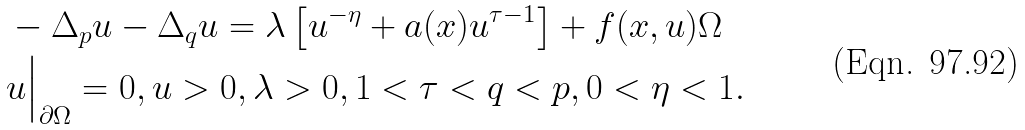<formula> <loc_0><loc_0><loc_500><loc_500>& - \Delta _ { p } u - \Delta _ { q } u = \lambda \left [ u ^ { - \eta } + a ( x ) u ^ { \tau - 1 } \right ] + f ( x , u ) \Omega \\ & u \Big | _ { \partial \Omega } = 0 , u > 0 , \lambda > 0 , 1 < \tau < q < p , 0 < \eta < 1 .</formula> 